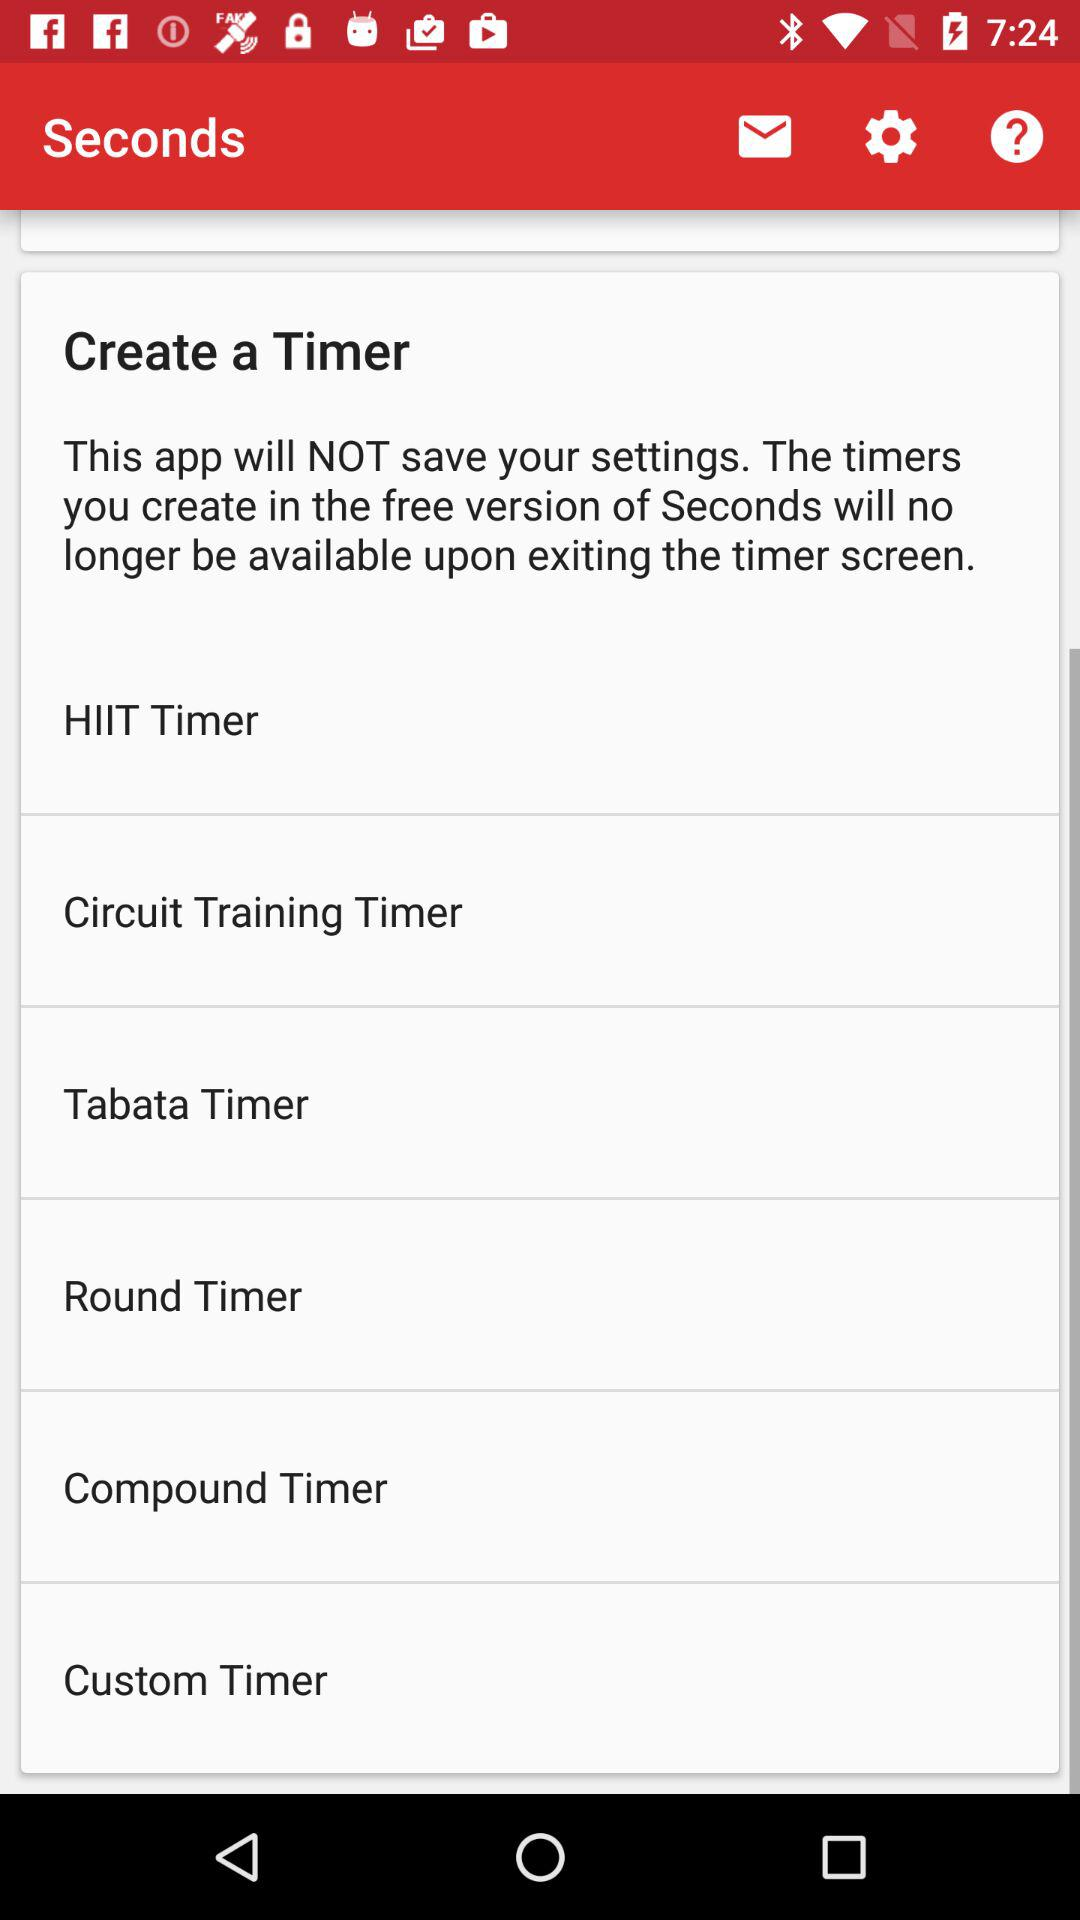How many timers are available?
Answer the question using a single word or phrase. 6 